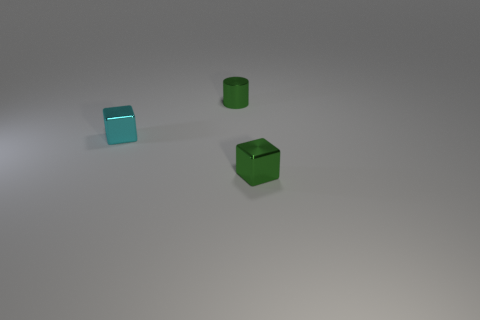Is there anything else of the same color as the small metallic cylinder?
Provide a short and direct response. Yes. There is a green thing that is behind the cyan block; does it have the same size as the green metal object in front of the tiny cyan metallic cube?
Your answer should be compact. Yes. The green metal object behind the tiny green object that is right of the small green cylinder is what shape?
Your answer should be compact. Cylinder. There is a green metallic cube; does it have the same size as the green metallic thing behind the small cyan metal block?
Provide a succinct answer. Yes. There is a green metallic object that is behind the cube in front of the shiny cube left of the small cylinder; what size is it?
Offer a very short reply. Small. What number of objects are tiny things on the right side of the cyan thing or small green metallic objects?
Offer a terse response. 2. What number of tiny metal things are in front of the thing in front of the cyan cube?
Offer a terse response. 0. Is the number of cyan blocks behind the green metallic block greater than the number of small cyan metal blocks?
Offer a very short reply. No. There is a metallic thing that is to the right of the cyan shiny object and in front of the green shiny cylinder; what size is it?
Give a very brief answer. Small. The small thing that is both right of the cyan shiny object and in front of the green shiny cylinder has what shape?
Your answer should be very brief. Cube. 